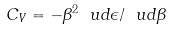<formula> <loc_0><loc_0><loc_500><loc_500>C _ { V } = - \beta ^ { 2 } \ u d \epsilon / \ u d \beta</formula> 